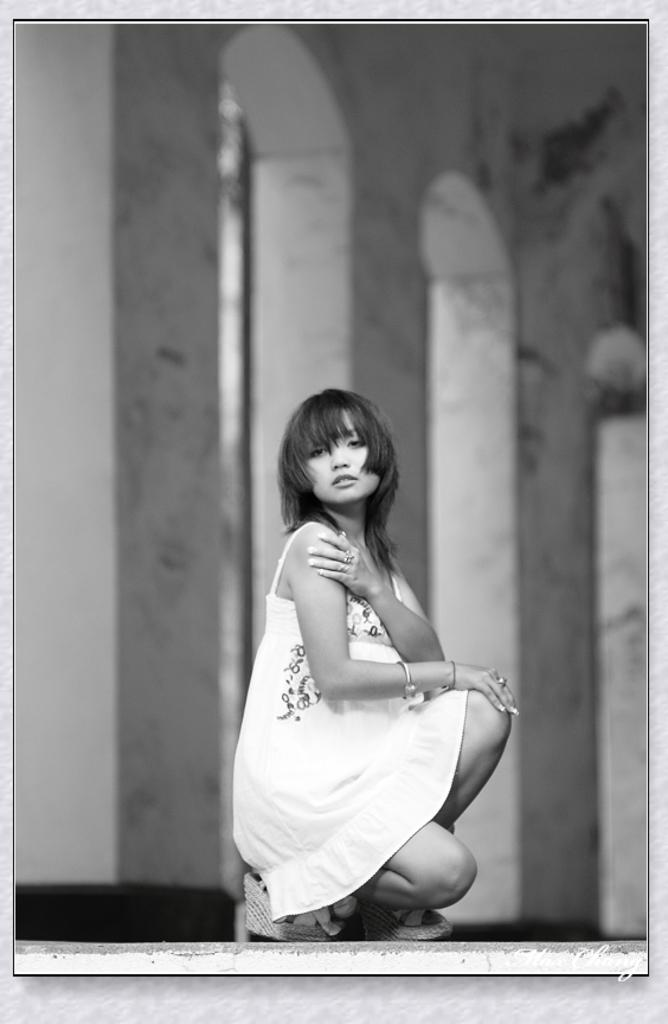Who is the main subject in the image? There is a woman in the image. What is the woman doing in the image? The woman is sitting on a shoe. What is the woman wearing in the image? The woman is wearing a white dress. What can be seen in the background of the image? There is a building with pillars in the background of the image. What type of popcorn is the woman eating in the image? There is no popcorn present in the image; the woman is sitting on a shoe. Are the woman's friends attacking her in the image? There is no indication of an attack or the presence of friends in the image. 